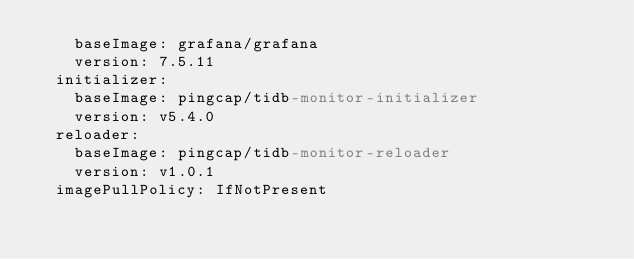Convert code to text. <code><loc_0><loc_0><loc_500><loc_500><_YAML_>    baseImage: grafana/grafana
    version: 7.5.11
  initializer:
    baseImage: pingcap/tidb-monitor-initializer
    version: v5.4.0
  reloader:
    baseImage: pingcap/tidb-monitor-reloader
    version: v1.0.1
  imagePullPolicy: IfNotPresent
</code> 